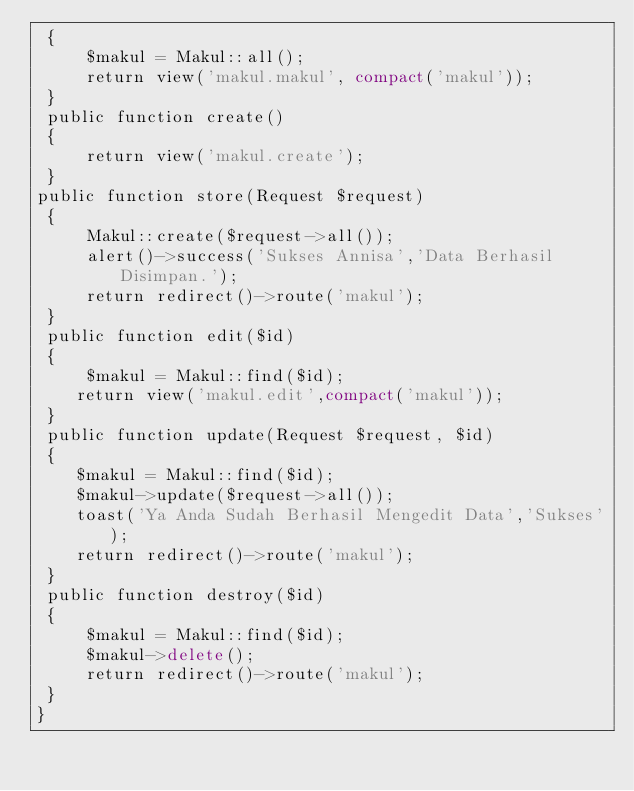<code> <loc_0><loc_0><loc_500><loc_500><_PHP_> {
     $makul = Makul::all();
     return view('makul.makul', compact('makul'));
 }
 public function create()
 {
     return view('makul.create');
 }
public function store(Request $request)
 {
     Makul::create($request->all());
     alert()->success('Sukses Annisa','Data Berhasil Disimpan.');
     return redirect()->route('makul');
 }
 public function edit($id)
 {
     $makul = Makul::find($id);
    return view('makul.edit',compact('makul'));
 }
 public function update(Request $request, $id)
 {
    $makul = Makul::find($id);
    $makul->update($request->all());
    toast('Ya Anda Sudah Berhasil Mengedit Data','Sukses');
    return redirect()->route('makul');
 }
 public function destroy($id)
 {
     $makul = Makul::find($id);
     $makul->delete();
     return redirect()->route('makul');
 }
}</code> 